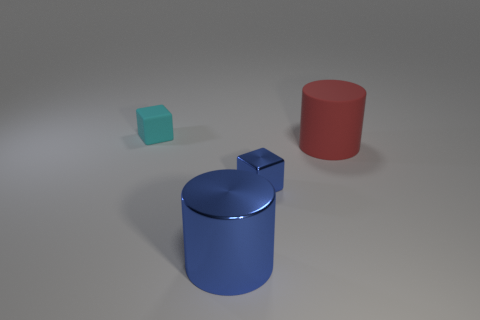Is the color of the metal cylinder the same as the small metallic cube?
Provide a succinct answer. Yes. What number of tiny shiny cubes are on the right side of the red object?
Provide a succinct answer. 0. Is the number of tiny shiny objects behind the big blue shiny object the same as the number of big blue cylinders?
Offer a very short reply. Yes. How many things are tiny blue metallic things or big green blocks?
Give a very brief answer. 1. There is a large red object that is behind the metallic object that is on the right side of the blue cylinder; what shape is it?
Ensure brevity in your answer.  Cylinder. There is a object that is made of the same material as the red cylinder; what is its shape?
Ensure brevity in your answer.  Cube. There is a blue metal object that is on the left side of the block in front of the tiny cyan matte thing; how big is it?
Your response must be concise. Large. The red matte thing has what shape?
Your answer should be very brief. Cylinder. How many tiny things are either things or purple blocks?
Your response must be concise. 2. What size is the other thing that is the same shape as the tiny cyan thing?
Offer a terse response. Small. 